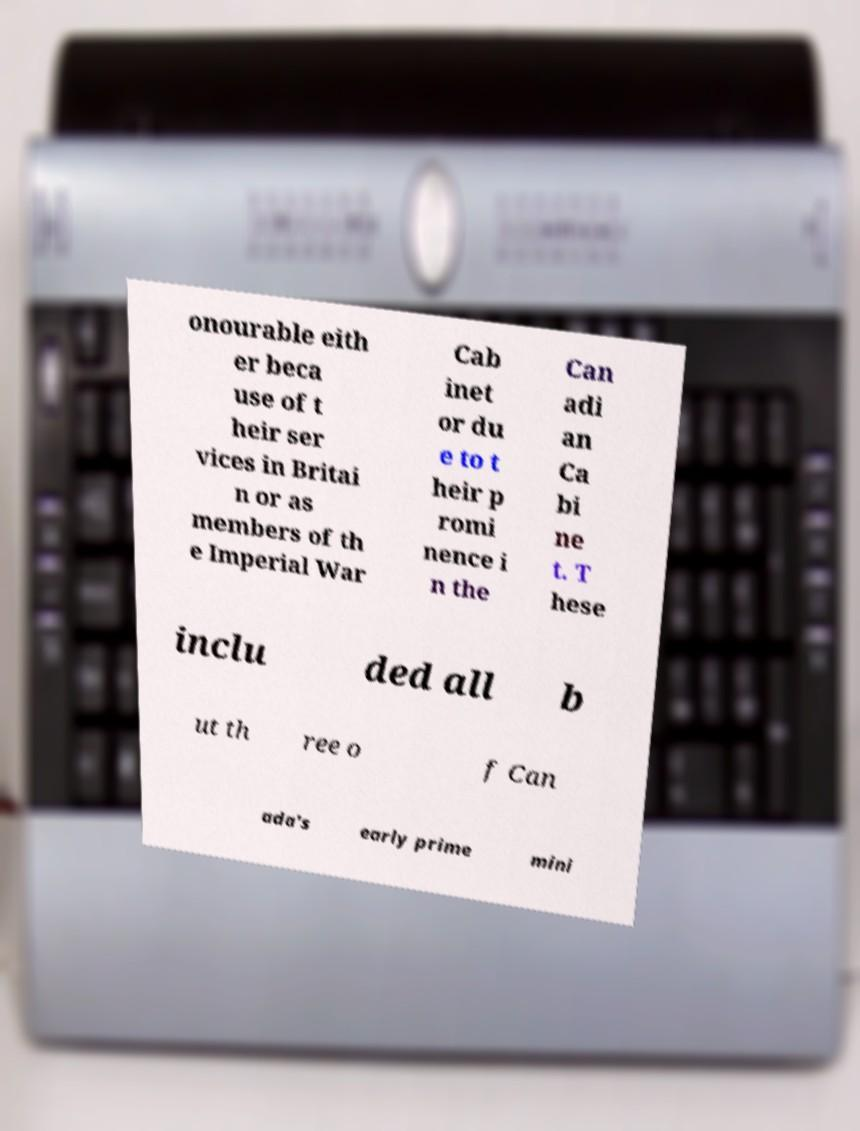Could you extract and type out the text from this image? onourable eith er beca use of t heir ser vices in Britai n or as members of th e Imperial War Cab inet or du e to t heir p romi nence i n the Can adi an Ca bi ne t. T hese inclu ded all b ut th ree o f Can ada's early prime mini 